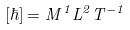Convert formula to latex. <formula><loc_0><loc_0><loc_500><loc_500>[ \hbar { ] } = M ^ { 1 } L ^ { 2 } T ^ { - 1 }</formula> 